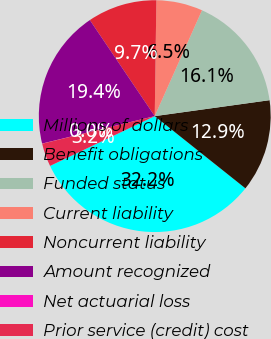Convert chart. <chart><loc_0><loc_0><loc_500><loc_500><pie_chart><fcel>Millions of dollars<fcel>Benefit obligations<fcel>Funded status<fcel>Current liability<fcel>Noncurrent liability<fcel>Amount recognized<fcel>Net actuarial loss<fcel>Prior service (credit) cost<nl><fcel>32.23%<fcel>12.9%<fcel>16.12%<fcel>6.46%<fcel>9.68%<fcel>19.35%<fcel>0.02%<fcel>3.24%<nl></chart> 